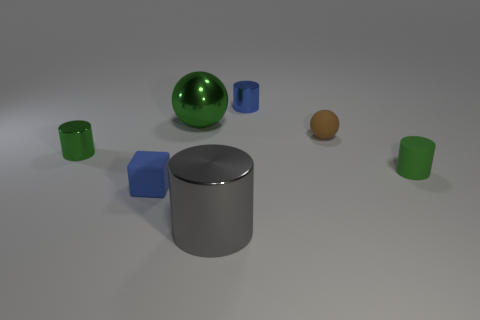Subtract all metallic cylinders. How many cylinders are left? 1 Subtract all blue cylinders. How many cylinders are left? 3 Subtract all cylinders. How many objects are left? 3 Subtract 0 yellow cylinders. How many objects are left? 7 Subtract 1 blocks. How many blocks are left? 0 Subtract all red cylinders. Subtract all green cubes. How many cylinders are left? 4 Subtract all cyan cylinders. How many red spheres are left? 0 Subtract all gray shiny objects. Subtract all tiny green shiny things. How many objects are left? 5 Add 4 gray shiny things. How many gray shiny things are left? 5 Add 3 tiny green cylinders. How many tiny green cylinders exist? 5 